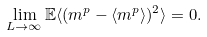<formula> <loc_0><loc_0><loc_500><loc_500>\lim _ { L \rightarrow \infty } { \mathbb { E } } \langle ( m ^ { p } - \langle m ^ { p } \rangle ) ^ { 2 } \rangle = 0 .</formula> 